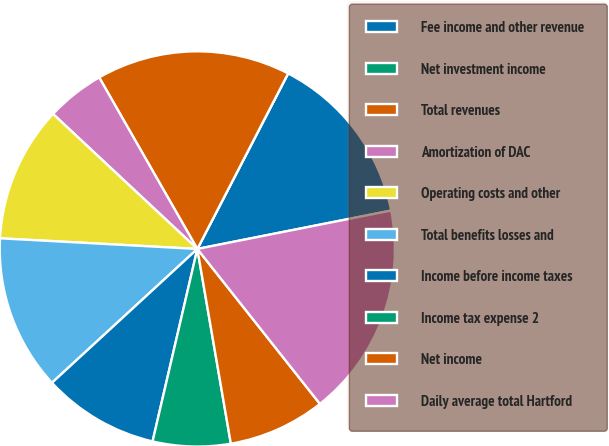Convert chart to OTSL. <chart><loc_0><loc_0><loc_500><loc_500><pie_chart><fcel>Fee income and other revenue<fcel>Net investment income<fcel>Total revenues<fcel>Amortization of DAC<fcel>Operating costs and other<fcel>Total benefits losses and<fcel>Income before income taxes<fcel>Income tax expense 2<fcel>Net income<fcel>Daily average total Hartford<nl><fcel>14.29%<fcel>0.0%<fcel>15.87%<fcel>4.76%<fcel>11.11%<fcel>12.7%<fcel>9.52%<fcel>6.35%<fcel>7.94%<fcel>17.46%<nl></chart> 